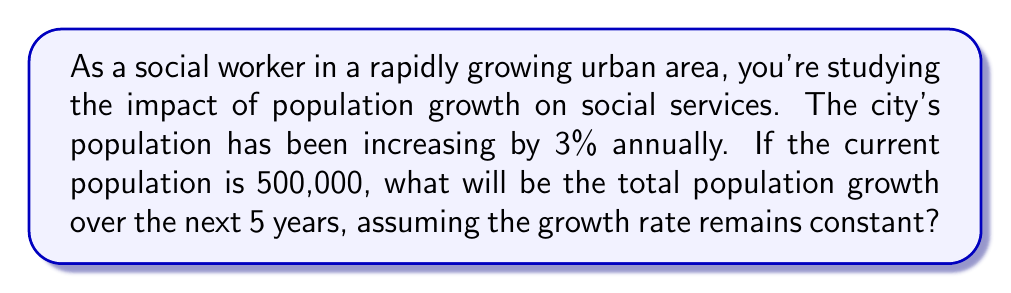Solve this math problem. To solve this problem, we need to use the concept of geometric series, as the population is growing by a constant percentage each year.

Let's break it down step-by-step:

1) The initial population is $P_0 = 500,000$.

2) The growth rate is 3% per year, so the common ratio is $r = 1 + 0.03 = 1.03$.

3) We need to calculate the population for each of the next 5 years:

   Year 1: $P_1 = 500,000 \times 1.03 = 515,000$
   Year 2: $P_2 = 515,000 \times 1.03 = 530,450$
   Year 3: $P_3 = 530,450 \times 1.03 = 546,363.5$
   Year 4: $P_4 = 546,363.5 \times 1.03 = 562,754.405$
   Year 5: $P_5 = 562,754.405 \times 1.03 = 579,637.03715$

4) The total population growth is the difference between the final and initial population:

   $\text{Total Growth} = P_5 - P_0 = 579,637.03715 - 500,000 = 79,637.03715$

5) We can also calculate this using the formula for the sum of a geometric series:

   $S_n = a\frac{1-r^n}{1-r}$, where $a$ is the first term, $r$ is the common ratio, and $n$ is the number of terms.

   In our case, $a = 500,000$, $r = 1.03$, and $n = 5$.

   $S_5 = 500,000\frac{1-1.03^5}{1-1.03} = 500,000\frac{1-1.159274}{-0.03} = 579,637.03715$

   The total growth is then $579,637.03715 - 500,000 = 79,637.03715$

This growth in population would likely put significant strain on existing social services, necessitating careful planning and resource allocation.
Answer: The total population growth over the next 5 years will be approximately 79,637 people. 